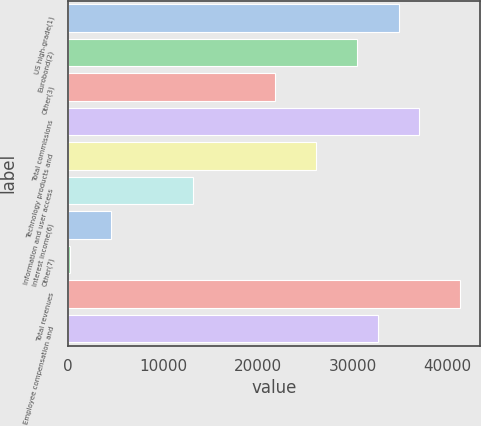<chart> <loc_0><loc_0><loc_500><loc_500><bar_chart><fcel>US high-grade(1)<fcel>Eurobond(2)<fcel>Other(3)<fcel>Total commissions<fcel>Technology products and<fcel>Information and user access<fcel>Interest income(6)<fcel>Other(7)<fcel>Total revenues<fcel>Employee compensation and<nl><fcel>34815<fcel>30486<fcel>21828<fcel>36979.5<fcel>26157<fcel>13170<fcel>4512<fcel>183<fcel>41308.5<fcel>32650.5<nl></chart> 